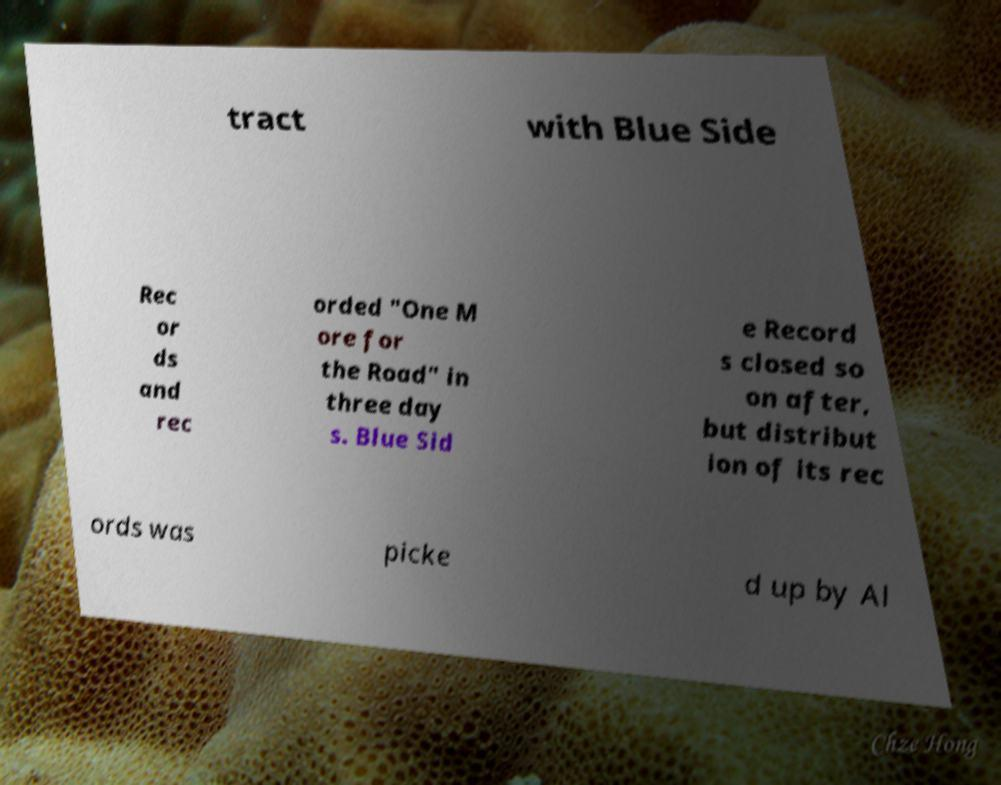Please identify and transcribe the text found in this image. tract with Blue Side Rec or ds and rec orded "One M ore for the Road" in three day s. Blue Sid e Record s closed so on after, but distribut ion of its rec ords was picke d up by Al 